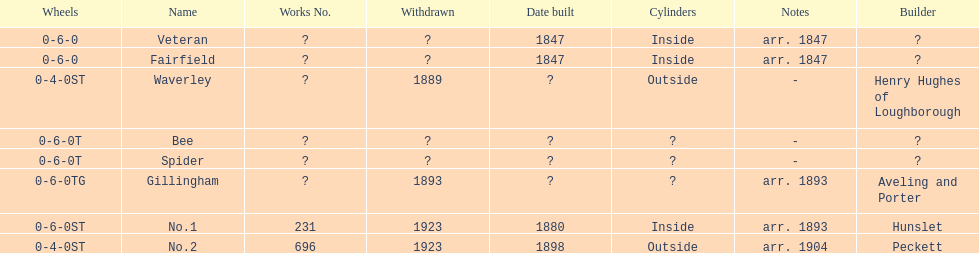How long after fairfield was no. 1 built? 33 years. 